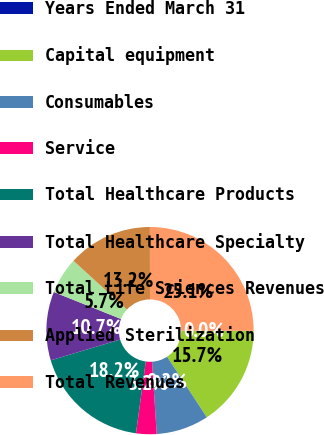Convert chart. <chart><loc_0><loc_0><loc_500><loc_500><pie_chart><fcel>Years Ended March 31<fcel>Capital equipment<fcel>Consumables<fcel>Service<fcel>Total Healthcare Products<fcel>Total Healthcare Specialty<fcel>Total Life Sciences Revenues<fcel>Applied Sterilization<fcel>Total Revenues<nl><fcel>0.02%<fcel>15.71%<fcel>8.2%<fcel>3.19%<fcel>18.21%<fcel>10.7%<fcel>5.7%<fcel>13.21%<fcel>25.05%<nl></chart> 